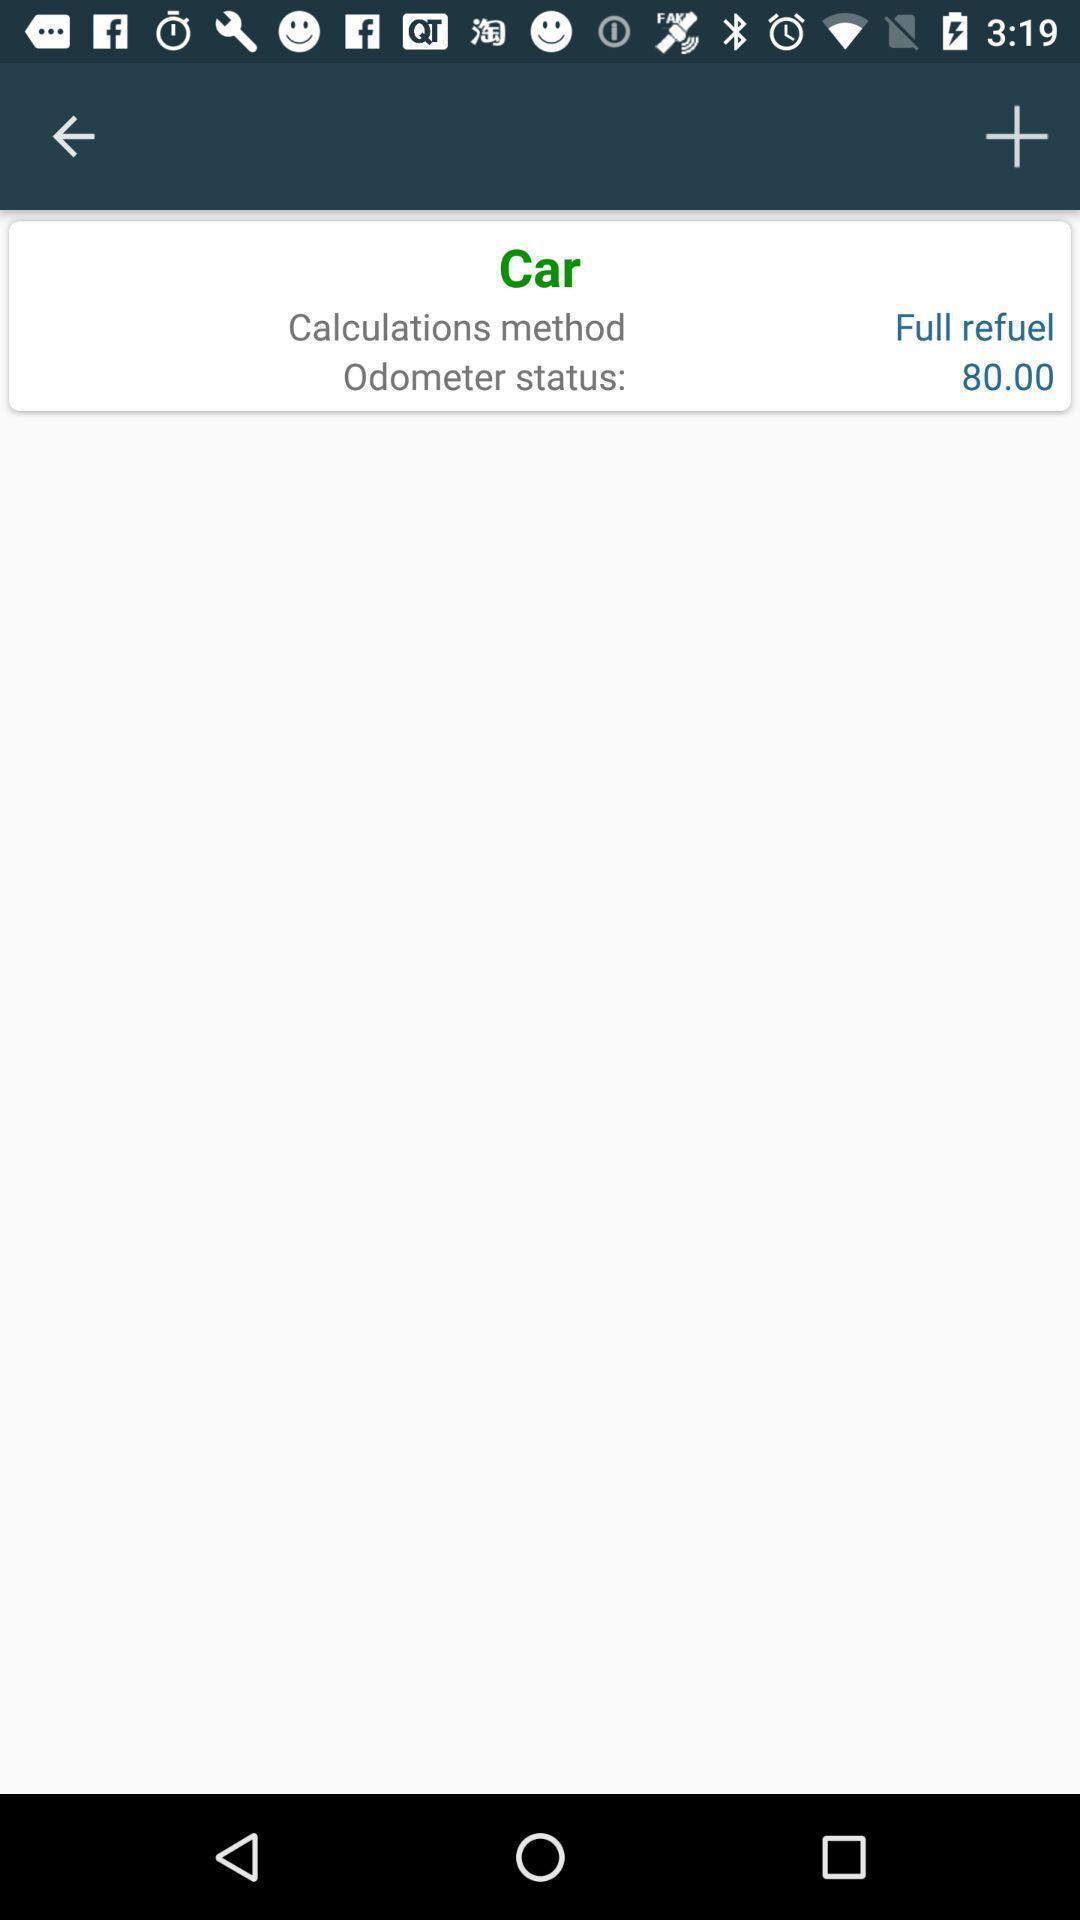Provide a textual representation of this image. Page with calculations on a mileage tracking apps. 